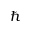Convert formula to latex. <formula><loc_0><loc_0><loc_500><loc_500>\hbar</formula> 